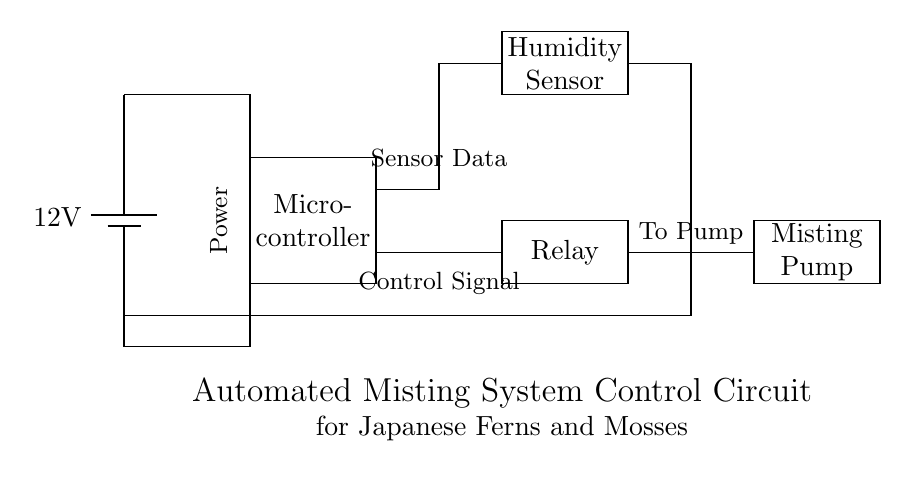What is the voltage supplied to the circuit? The voltage supplied to the circuit is indicated by the battery in the diagram, which shows a potential difference of twelve volts.
Answer: twelve volts What component is used to detect humidity? The component responsible for detecting humidity in the circuit is labeled as the Humidity Sensor, which is specifically designed to measure moisture levels.
Answer: Humidity Sensor How many main components are in the circuit? The circuit diagram features four main components: the battery, microcontroller, humidity sensor, and misting pump. Counting these gives a total of four.
Answer: four What type of signal does the microcontroller send to the relay? The microcontroller sends a control signal to the relay, responsible for activating or deactivating the misting pump based on the sensor data.
Answer: Control Signal How does the power supply connect to the microcontroller? The power supply connects to the microcontroller through a direct line indicated in the diagram, which shows the flow of electricity from the battery to the input of the microcontroller.
Answer: Direct connection What is the primary function of the relay in this circuit? The primary function of the relay in this circuit is to act as a switch that controls the operation of the misting pump based on the signal received from the microcontroller.
Answer: To control the misting pump Which component is responsible for pumping the mist? The component responsible for pumping the mist is the Misting Pump, as indicated in the circuit diagram. It is activated when a signal is sent from the relay.
Answer: Misting Pump 